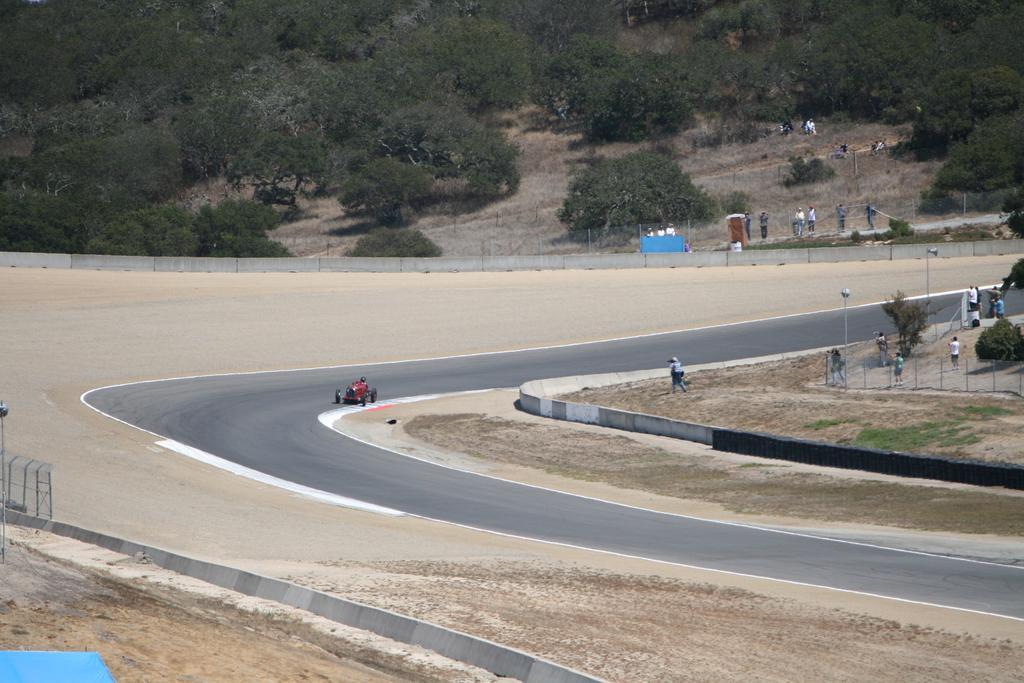Describe this image in one or two sentences. In this picture I can see group of people, there is a vehicle on the road, there are poles, fence, and in the background there are trees. 